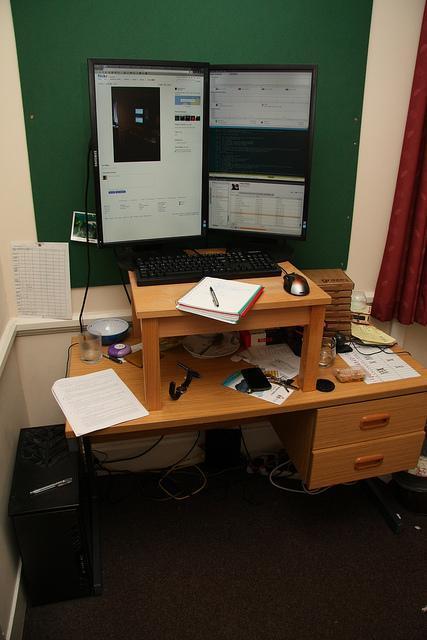How many computer monitors are on the desk?
Give a very brief answer. 2. How many tvs are there?
Give a very brief answer. 3. 